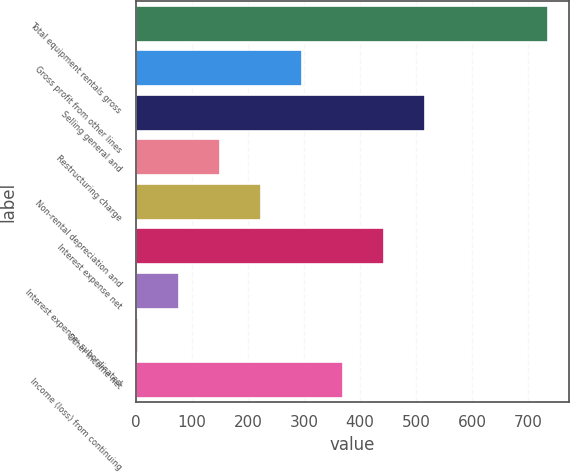Convert chart to OTSL. <chart><loc_0><loc_0><loc_500><loc_500><bar_chart><fcel>Total equipment rentals gross<fcel>Gross profit from other lines<fcel>Selling general and<fcel>Restructuring charge<fcel>Non-rental depreciation and<fcel>Interest expense net<fcel>Interest expense- subordinated<fcel>Other income net<fcel>Income (loss) from continuing<nl><fcel>736<fcel>296.2<fcel>516.1<fcel>149.6<fcel>222.9<fcel>442.8<fcel>76.3<fcel>3<fcel>369.5<nl></chart> 